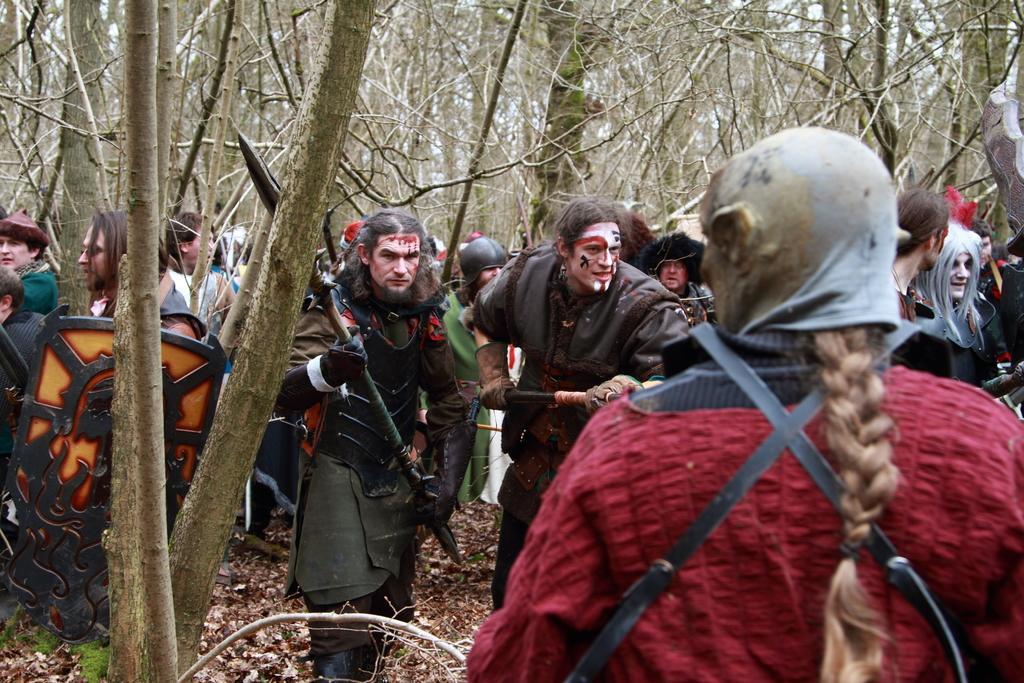Describe this image in one or two sentences. In this image we can see few people standing on the ground and holding few objects and there are few trees in the background. 